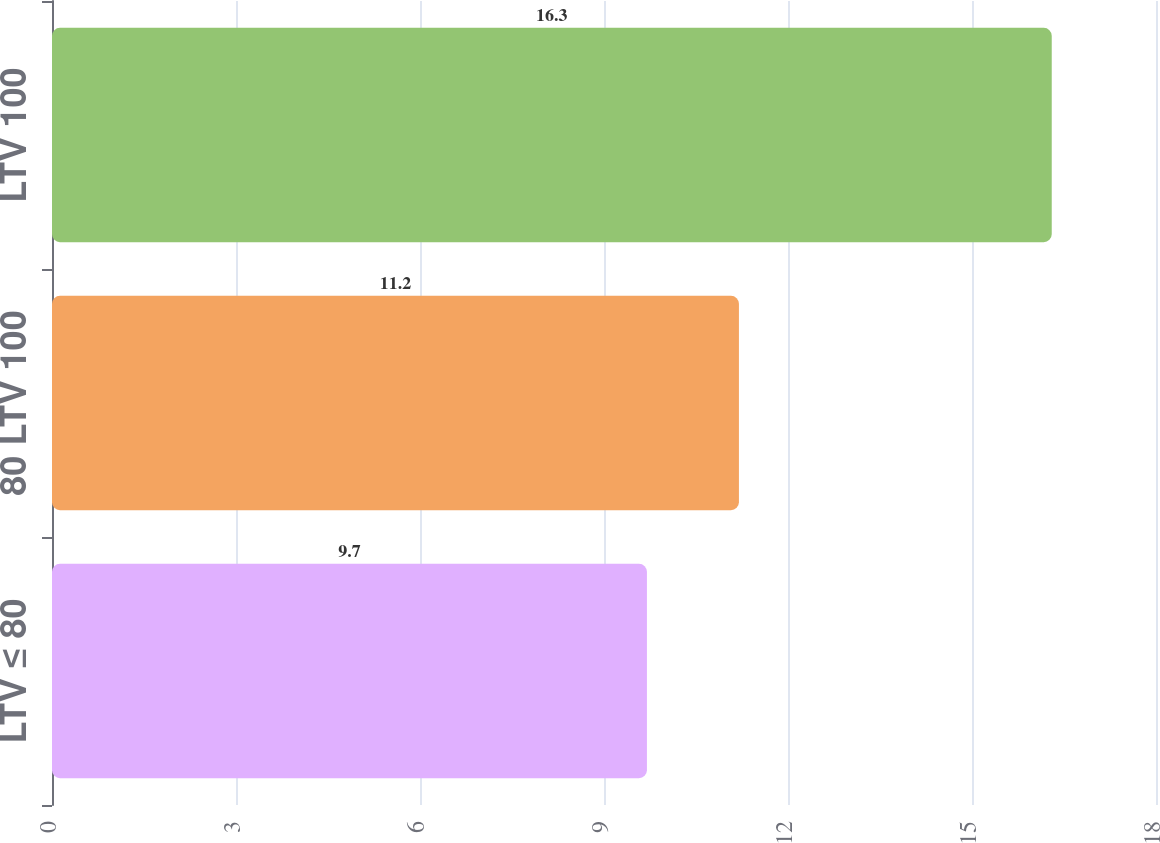Convert chart to OTSL. <chart><loc_0><loc_0><loc_500><loc_500><bar_chart><fcel>LTV ≤ 80<fcel>80 LTV 100<fcel>LTV 100<nl><fcel>9.7<fcel>11.2<fcel>16.3<nl></chart> 